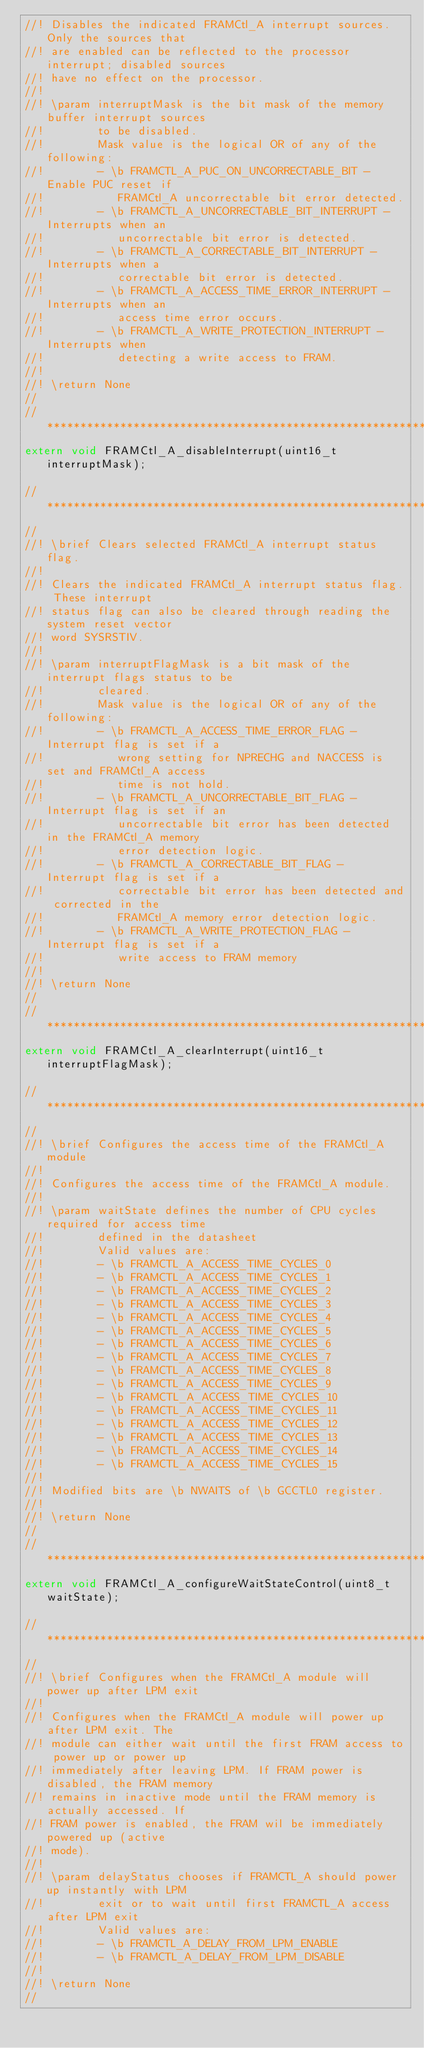Convert code to text. <code><loc_0><loc_0><loc_500><loc_500><_C_>//! Disables the indicated FRAMCtl_A interrupt sources.  Only the sources that
//! are enabled can be reflected to the processor interrupt; disabled sources
//! have no effect on the processor.
//!
//! \param interruptMask is the bit mask of the memory buffer interrupt sources
//!        to be disabled.
//!        Mask value is the logical OR of any of the following:
//!        - \b FRAMCTL_A_PUC_ON_UNCORRECTABLE_BIT - Enable PUC reset if
//!           FRAMCtl_A uncorrectable bit error detected.
//!        - \b FRAMCTL_A_UNCORRECTABLE_BIT_INTERRUPT - Interrupts when an
//!           uncorrectable bit error is detected.
//!        - \b FRAMCTL_A_CORRECTABLE_BIT_INTERRUPT - Interrupts when a
//!           correctable bit error is detected.
//!        - \b FRAMCTL_A_ACCESS_TIME_ERROR_INTERRUPT - Interrupts when an
//!           access time error occurs.
//!        - \b FRAMCTL_A_WRITE_PROTECTION_INTERRUPT - Interrupts when
//!           detecting a write access to FRAM.
//!
//! \return None
//
//*****************************************************************************
extern void FRAMCtl_A_disableInterrupt(uint16_t interruptMask);

//*****************************************************************************
//
//! \brief Clears selected FRAMCtl_A interrupt status flag.
//!
//! Clears the indicated FRAMCtl_A interrupt status flag. These interrupt
//! status flag can also be cleared through reading the system reset vector
//! word SYSRSTIV.
//!
//! \param interruptFlagMask is a bit mask of the interrupt flags status to be
//!        cleared.
//!        Mask value is the logical OR of any of the following:
//!        - \b FRAMCTL_A_ACCESS_TIME_ERROR_FLAG - Interrupt flag is set if a
//!           wrong setting for NPRECHG and NACCESS is set and FRAMCtl_A access
//!           time is not hold.
//!        - \b FRAMCTL_A_UNCORRECTABLE_BIT_FLAG - Interrupt flag is set if an
//!           uncorrectable bit error has been detected in the FRAMCtl_A memory
//!           error detection logic.
//!        - \b FRAMCTL_A_CORRECTABLE_BIT_FLAG - Interrupt flag is set if a
//!           correctable bit error has been detected and corrected in the
//!           FRAMCtl_A memory error detection logic.
//!        - \b FRAMCTL_A_WRITE_PROTECTION_FLAG - Interrupt flag is set if a
//!           write access to FRAM memory
//!
//! \return None
//
//*****************************************************************************
extern void FRAMCtl_A_clearInterrupt(uint16_t interruptFlagMask);

//*****************************************************************************
//
//! \brief Configures the access time of the FRAMCtl_A module
//!
//! Configures the access time of the FRAMCtl_A module.
//!
//! \param waitState defines the number of CPU cycles required for access time
//!        defined in the datasheet
//!        Valid values are:
//!        - \b FRAMCTL_A_ACCESS_TIME_CYCLES_0
//!        - \b FRAMCTL_A_ACCESS_TIME_CYCLES_1
//!        - \b FRAMCTL_A_ACCESS_TIME_CYCLES_2
//!        - \b FRAMCTL_A_ACCESS_TIME_CYCLES_3
//!        - \b FRAMCTL_A_ACCESS_TIME_CYCLES_4
//!        - \b FRAMCTL_A_ACCESS_TIME_CYCLES_5
//!        - \b FRAMCTL_A_ACCESS_TIME_CYCLES_6
//!        - \b FRAMCTL_A_ACCESS_TIME_CYCLES_7
//!        - \b FRAMCTL_A_ACCESS_TIME_CYCLES_8
//!        - \b FRAMCTL_A_ACCESS_TIME_CYCLES_9
//!        - \b FRAMCTL_A_ACCESS_TIME_CYCLES_10
//!        - \b FRAMCTL_A_ACCESS_TIME_CYCLES_11
//!        - \b FRAMCTL_A_ACCESS_TIME_CYCLES_12
//!        - \b FRAMCTL_A_ACCESS_TIME_CYCLES_13
//!        - \b FRAMCTL_A_ACCESS_TIME_CYCLES_14
//!        - \b FRAMCTL_A_ACCESS_TIME_CYCLES_15
//!
//! Modified bits are \b NWAITS of \b GCCTL0 register.
//!
//! \return None
//
//*****************************************************************************
extern void FRAMCtl_A_configureWaitStateControl(uint8_t waitState);

//*****************************************************************************
//
//! \brief Configures when the FRAMCtl_A module will power up after LPM exit
//!
//! Configures when the FRAMCtl_A module will power up after LPM exit. The
//! module can either wait until the first FRAM access to power up or power up
//! immediately after leaving LPM. If FRAM power is disabled, the FRAM memory
//! remains in inactive mode until the FRAM memory is actually accessed. If
//! FRAM power is enabled, the FRAM wil be immediately powered up (active
//! mode).
//!
//! \param delayStatus chooses if FRAMCTL_A should power up instantly with LPM
//!        exit or to wait until first FRAMCTL_A access after LPM exit
//!        Valid values are:
//!        - \b FRAMCTL_A_DELAY_FROM_LPM_ENABLE
//!        - \b FRAMCTL_A_DELAY_FROM_LPM_DISABLE
//!
//! \return None
//</code> 